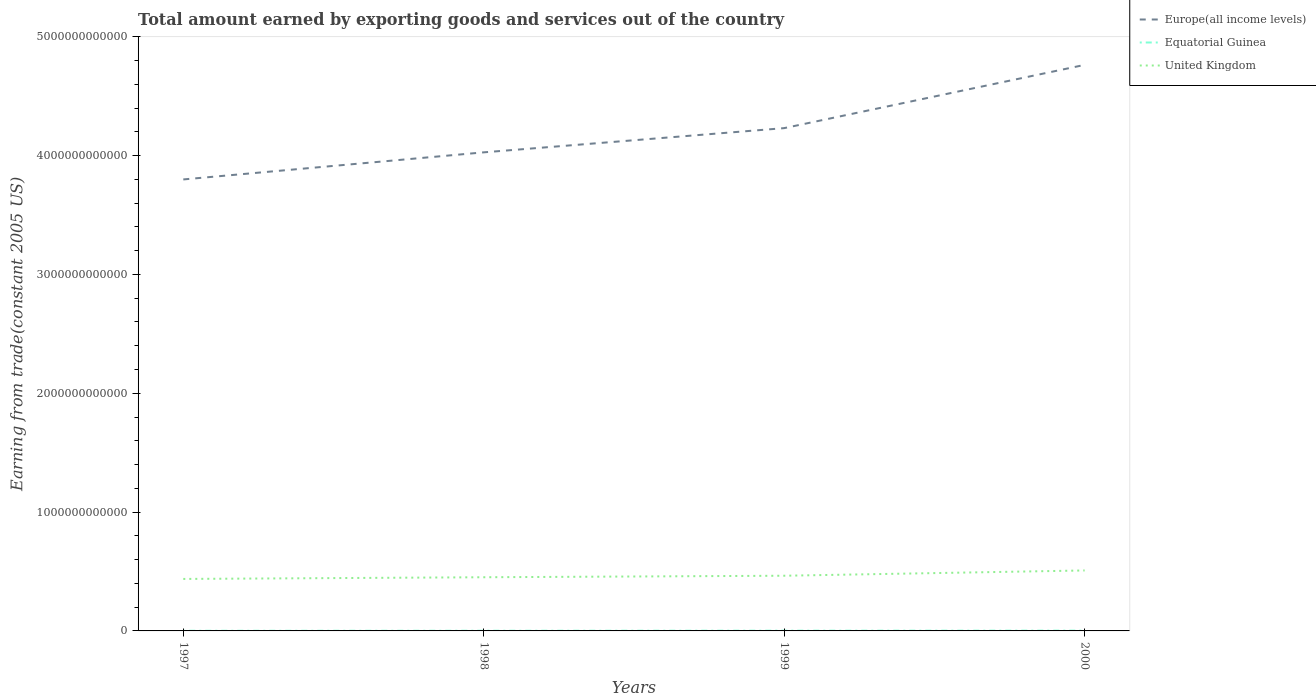Does the line corresponding to United Kingdom intersect with the line corresponding to Equatorial Guinea?
Ensure brevity in your answer.  No. Across all years, what is the maximum total amount earned by exporting goods and services in Europe(all income levels)?
Provide a succinct answer. 3.80e+12. In which year was the total amount earned by exporting goods and services in United Kingdom maximum?
Offer a very short reply. 1997. What is the total total amount earned by exporting goods and services in Equatorial Guinea in the graph?
Offer a very short reply. -2.87e+08. What is the difference between the highest and the second highest total amount earned by exporting goods and services in United Kingdom?
Your response must be concise. 7.14e+1. Is the total amount earned by exporting goods and services in Equatorial Guinea strictly greater than the total amount earned by exporting goods and services in Europe(all income levels) over the years?
Provide a succinct answer. Yes. What is the difference between two consecutive major ticks on the Y-axis?
Keep it short and to the point. 1.00e+12. Are the values on the major ticks of Y-axis written in scientific E-notation?
Give a very brief answer. No. Does the graph contain grids?
Ensure brevity in your answer.  No. Where does the legend appear in the graph?
Provide a short and direct response. Top right. How are the legend labels stacked?
Make the answer very short. Vertical. What is the title of the graph?
Make the answer very short. Total amount earned by exporting goods and services out of the country. Does "Israel" appear as one of the legend labels in the graph?
Provide a succinct answer. No. What is the label or title of the Y-axis?
Make the answer very short. Earning from trade(constant 2005 US). What is the Earning from trade(constant 2005 US) in Europe(all income levels) in 1997?
Offer a terse response. 3.80e+12. What is the Earning from trade(constant 2005 US) of Equatorial Guinea in 1997?
Your answer should be compact. 1.25e+09. What is the Earning from trade(constant 2005 US) of United Kingdom in 1997?
Your answer should be very brief. 4.38e+11. What is the Earning from trade(constant 2005 US) in Europe(all income levels) in 1998?
Offer a very short reply. 4.03e+12. What is the Earning from trade(constant 2005 US) in Equatorial Guinea in 1998?
Your answer should be compact. 1.53e+09. What is the Earning from trade(constant 2005 US) of United Kingdom in 1998?
Keep it short and to the point. 4.52e+11. What is the Earning from trade(constant 2005 US) in Europe(all income levels) in 1999?
Provide a succinct answer. 4.23e+12. What is the Earning from trade(constant 2005 US) in Equatorial Guinea in 1999?
Keep it short and to the point. 2.06e+09. What is the Earning from trade(constant 2005 US) of United Kingdom in 1999?
Your response must be concise. 4.64e+11. What is the Earning from trade(constant 2005 US) of Europe(all income levels) in 2000?
Provide a short and direct response. 4.76e+12. What is the Earning from trade(constant 2005 US) of Equatorial Guinea in 2000?
Make the answer very short. 2.40e+09. What is the Earning from trade(constant 2005 US) in United Kingdom in 2000?
Provide a short and direct response. 5.09e+11. Across all years, what is the maximum Earning from trade(constant 2005 US) of Europe(all income levels)?
Provide a succinct answer. 4.76e+12. Across all years, what is the maximum Earning from trade(constant 2005 US) in Equatorial Guinea?
Ensure brevity in your answer.  2.40e+09. Across all years, what is the maximum Earning from trade(constant 2005 US) of United Kingdom?
Provide a short and direct response. 5.09e+11. Across all years, what is the minimum Earning from trade(constant 2005 US) in Europe(all income levels)?
Make the answer very short. 3.80e+12. Across all years, what is the minimum Earning from trade(constant 2005 US) in Equatorial Guinea?
Your answer should be compact. 1.25e+09. Across all years, what is the minimum Earning from trade(constant 2005 US) in United Kingdom?
Your answer should be very brief. 4.38e+11. What is the total Earning from trade(constant 2005 US) of Europe(all income levels) in the graph?
Offer a terse response. 1.68e+13. What is the total Earning from trade(constant 2005 US) in Equatorial Guinea in the graph?
Provide a succinct answer. 7.24e+09. What is the total Earning from trade(constant 2005 US) in United Kingdom in the graph?
Your response must be concise. 1.86e+12. What is the difference between the Earning from trade(constant 2005 US) in Europe(all income levels) in 1997 and that in 1998?
Offer a terse response. -2.28e+11. What is the difference between the Earning from trade(constant 2005 US) of Equatorial Guinea in 1997 and that in 1998?
Offer a terse response. -2.87e+08. What is the difference between the Earning from trade(constant 2005 US) of United Kingdom in 1997 and that in 1998?
Keep it short and to the point. -1.42e+1. What is the difference between the Earning from trade(constant 2005 US) in Europe(all income levels) in 1997 and that in 1999?
Ensure brevity in your answer.  -4.32e+11. What is the difference between the Earning from trade(constant 2005 US) of Equatorial Guinea in 1997 and that in 1999?
Provide a succinct answer. -8.08e+08. What is the difference between the Earning from trade(constant 2005 US) of United Kingdom in 1997 and that in 1999?
Offer a terse response. -2.70e+1. What is the difference between the Earning from trade(constant 2005 US) of Europe(all income levels) in 1997 and that in 2000?
Give a very brief answer. -9.64e+11. What is the difference between the Earning from trade(constant 2005 US) in Equatorial Guinea in 1997 and that in 2000?
Provide a succinct answer. -1.15e+09. What is the difference between the Earning from trade(constant 2005 US) of United Kingdom in 1997 and that in 2000?
Your answer should be very brief. -7.14e+1. What is the difference between the Earning from trade(constant 2005 US) in Europe(all income levels) in 1998 and that in 1999?
Your answer should be very brief. -2.04e+11. What is the difference between the Earning from trade(constant 2005 US) in Equatorial Guinea in 1998 and that in 1999?
Offer a terse response. -5.22e+08. What is the difference between the Earning from trade(constant 2005 US) of United Kingdom in 1998 and that in 1999?
Keep it short and to the point. -1.28e+1. What is the difference between the Earning from trade(constant 2005 US) in Europe(all income levels) in 1998 and that in 2000?
Provide a succinct answer. -7.36e+11. What is the difference between the Earning from trade(constant 2005 US) in Equatorial Guinea in 1998 and that in 2000?
Offer a very short reply. -8.65e+08. What is the difference between the Earning from trade(constant 2005 US) of United Kingdom in 1998 and that in 2000?
Provide a succinct answer. -5.72e+1. What is the difference between the Earning from trade(constant 2005 US) of Europe(all income levels) in 1999 and that in 2000?
Offer a very short reply. -5.32e+11. What is the difference between the Earning from trade(constant 2005 US) in Equatorial Guinea in 1999 and that in 2000?
Give a very brief answer. -3.43e+08. What is the difference between the Earning from trade(constant 2005 US) in United Kingdom in 1999 and that in 2000?
Give a very brief answer. -4.44e+1. What is the difference between the Earning from trade(constant 2005 US) in Europe(all income levels) in 1997 and the Earning from trade(constant 2005 US) in Equatorial Guinea in 1998?
Give a very brief answer. 3.80e+12. What is the difference between the Earning from trade(constant 2005 US) in Europe(all income levels) in 1997 and the Earning from trade(constant 2005 US) in United Kingdom in 1998?
Offer a terse response. 3.35e+12. What is the difference between the Earning from trade(constant 2005 US) in Equatorial Guinea in 1997 and the Earning from trade(constant 2005 US) in United Kingdom in 1998?
Provide a succinct answer. -4.50e+11. What is the difference between the Earning from trade(constant 2005 US) in Europe(all income levels) in 1997 and the Earning from trade(constant 2005 US) in Equatorial Guinea in 1999?
Provide a short and direct response. 3.80e+12. What is the difference between the Earning from trade(constant 2005 US) in Europe(all income levels) in 1997 and the Earning from trade(constant 2005 US) in United Kingdom in 1999?
Ensure brevity in your answer.  3.33e+12. What is the difference between the Earning from trade(constant 2005 US) in Equatorial Guinea in 1997 and the Earning from trade(constant 2005 US) in United Kingdom in 1999?
Your answer should be compact. -4.63e+11. What is the difference between the Earning from trade(constant 2005 US) of Europe(all income levels) in 1997 and the Earning from trade(constant 2005 US) of Equatorial Guinea in 2000?
Give a very brief answer. 3.80e+12. What is the difference between the Earning from trade(constant 2005 US) in Europe(all income levels) in 1997 and the Earning from trade(constant 2005 US) in United Kingdom in 2000?
Ensure brevity in your answer.  3.29e+12. What is the difference between the Earning from trade(constant 2005 US) of Equatorial Guinea in 1997 and the Earning from trade(constant 2005 US) of United Kingdom in 2000?
Your answer should be compact. -5.08e+11. What is the difference between the Earning from trade(constant 2005 US) in Europe(all income levels) in 1998 and the Earning from trade(constant 2005 US) in Equatorial Guinea in 1999?
Ensure brevity in your answer.  4.03e+12. What is the difference between the Earning from trade(constant 2005 US) in Europe(all income levels) in 1998 and the Earning from trade(constant 2005 US) in United Kingdom in 1999?
Give a very brief answer. 3.56e+12. What is the difference between the Earning from trade(constant 2005 US) in Equatorial Guinea in 1998 and the Earning from trade(constant 2005 US) in United Kingdom in 1999?
Your answer should be compact. -4.63e+11. What is the difference between the Earning from trade(constant 2005 US) in Europe(all income levels) in 1998 and the Earning from trade(constant 2005 US) in Equatorial Guinea in 2000?
Provide a short and direct response. 4.02e+12. What is the difference between the Earning from trade(constant 2005 US) in Europe(all income levels) in 1998 and the Earning from trade(constant 2005 US) in United Kingdom in 2000?
Offer a terse response. 3.52e+12. What is the difference between the Earning from trade(constant 2005 US) in Equatorial Guinea in 1998 and the Earning from trade(constant 2005 US) in United Kingdom in 2000?
Give a very brief answer. -5.07e+11. What is the difference between the Earning from trade(constant 2005 US) in Europe(all income levels) in 1999 and the Earning from trade(constant 2005 US) in Equatorial Guinea in 2000?
Offer a terse response. 4.23e+12. What is the difference between the Earning from trade(constant 2005 US) in Europe(all income levels) in 1999 and the Earning from trade(constant 2005 US) in United Kingdom in 2000?
Keep it short and to the point. 3.72e+12. What is the difference between the Earning from trade(constant 2005 US) of Equatorial Guinea in 1999 and the Earning from trade(constant 2005 US) of United Kingdom in 2000?
Give a very brief answer. -5.07e+11. What is the average Earning from trade(constant 2005 US) in Europe(all income levels) per year?
Provide a succinct answer. 4.21e+12. What is the average Earning from trade(constant 2005 US) of Equatorial Guinea per year?
Your response must be concise. 1.81e+09. What is the average Earning from trade(constant 2005 US) in United Kingdom per year?
Your response must be concise. 4.66e+11. In the year 1997, what is the difference between the Earning from trade(constant 2005 US) of Europe(all income levels) and Earning from trade(constant 2005 US) of Equatorial Guinea?
Your answer should be very brief. 3.80e+12. In the year 1997, what is the difference between the Earning from trade(constant 2005 US) of Europe(all income levels) and Earning from trade(constant 2005 US) of United Kingdom?
Ensure brevity in your answer.  3.36e+12. In the year 1997, what is the difference between the Earning from trade(constant 2005 US) of Equatorial Guinea and Earning from trade(constant 2005 US) of United Kingdom?
Offer a very short reply. -4.36e+11. In the year 1998, what is the difference between the Earning from trade(constant 2005 US) of Europe(all income levels) and Earning from trade(constant 2005 US) of Equatorial Guinea?
Offer a very short reply. 4.03e+12. In the year 1998, what is the difference between the Earning from trade(constant 2005 US) in Europe(all income levels) and Earning from trade(constant 2005 US) in United Kingdom?
Offer a terse response. 3.58e+12. In the year 1998, what is the difference between the Earning from trade(constant 2005 US) of Equatorial Guinea and Earning from trade(constant 2005 US) of United Kingdom?
Offer a very short reply. -4.50e+11. In the year 1999, what is the difference between the Earning from trade(constant 2005 US) of Europe(all income levels) and Earning from trade(constant 2005 US) of Equatorial Guinea?
Your response must be concise. 4.23e+12. In the year 1999, what is the difference between the Earning from trade(constant 2005 US) in Europe(all income levels) and Earning from trade(constant 2005 US) in United Kingdom?
Make the answer very short. 3.77e+12. In the year 1999, what is the difference between the Earning from trade(constant 2005 US) in Equatorial Guinea and Earning from trade(constant 2005 US) in United Kingdom?
Provide a short and direct response. -4.62e+11. In the year 2000, what is the difference between the Earning from trade(constant 2005 US) of Europe(all income levels) and Earning from trade(constant 2005 US) of Equatorial Guinea?
Provide a short and direct response. 4.76e+12. In the year 2000, what is the difference between the Earning from trade(constant 2005 US) in Europe(all income levels) and Earning from trade(constant 2005 US) in United Kingdom?
Offer a very short reply. 4.25e+12. In the year 2000, what is the difference between the Earning from trade(constant 2005 US) in Equatorial Guinea and Earning from trade(constant 2005 US) in United Kingdom?
Your answer should be compact. -5.06e+11. What is the ratio of the Earning from trade(constant 2005 US) of Europe(all income levels) in 1997 to that in 1998?
Offer a very short reply. 0.94. What is the ratio of the Earning from trade(constant 2005 US) in Equatorial Guinea in 1997 to that in 1998?
Ensure brevity in your answer.  0.81. What is the ratio of the Earning from trade(constant 2005 US) of United Kingdom in 1997 to that in 1998?
Ensure brevity in your answer.  0.97. What is the ratio of the Earning from trade(constant 2005 US) in Europe(all income levels) in 1997 to that in 1999?
Make the answer very short. 0.9. What is the ratio of the Earning from trade(constant 2005 US) of Equatorial Guinea in 1997 to that in 1999?
Your answer should be compact. 0.61. What is the ratio of the Earning from trade(constant 2005 US) in United Kingdom in 1997 to that in 1999?
Your answer should be very brief. 0.94. What is the ratio of the Earning from trade(constant 2005 US) in Europe(all income levels) in 1997 to that in 2000?
Offer a terse response. 0.8. What is the ratio of the Earning from trade(constant 2005 US) of Equatorial Guinea in 1997 to that in 2000?
Offer a very short reply. 0.52. What is the ratio of the Earning from trade(constant 2005 US) in United Kingdom in 1997 to that in 2000?
Your response must be concise. 0.86. What is the ratio of the Earning from trade(constant 2005 US) in Europe(all income levels) in 1998 to that in 1999?
Your answer should be very brief. 0.95. What is the ratio of the Earning from trade(constant 2005 US) in Equatorial Guinea in 1998 to that in 1999?
Provide a short and direct response. 0.75. What is the ratio of the Earning from trade(constant 2005 US) of United Kingdom in 1998 to that in 1999?
Make the answer very short. 0.97. What is the ratio of the Earning from trade(constant 2005 US) in Europe(all income levels) in 1998 to that in 2000?
Your response must be concise. 0.85. What is the ratio of the Earning from trade(constant 2005 US) in Equatorial Guinea in 1998 to that in 2000?
Your answer should be compact. 0.64. What is the ratio of the Earning from trade(constant 2005 US) of United Kingdom in 1998 to that in 2000?
Offer a very short reply. 0.89. What is the ratio of the Earning from trade(constant 2005 US) in Europe(all income levels) in 1999 to that in 2000?
Give a very brief answer. 0.89. What is the ratio of the Earning from trade(constant 2005 US) of Equatorial Guinea in 1999 to that in 2000?
Your answer should be compact. 0.86. What is the ratio of the Earning from trade(constant 2005 US) of United Kingdom in 1999 to that in 2000?
Provide a short and direct response. 0.91. What is the difference between the highest and the second highest Earning from trade(constant 2005 US) in Europe(all income levels)?
Offer a very short reply. 5.32e+11. What is the difference between the highest and the second highest Earning from trade(constant 2005 US) of Equatorial Guinea?
Your answer should be very brief. 3.43e+08. What is the difference between the highest and the second highest Earning from trade(constant 2005 US) in United Kingdom?
Provide a succinct answer. 4.44e+1. What is the difference between the highest and the lowest Earning from trade(constant 2005 US) of Europe(all income levels)?
Offer a very short reply. 9.64e+11. What is the difference between the highest and the lowest Earning from trade(constant 2005 US) of Equatorial Guinea?
Your answer should be very brief. 1.15e+09. What is the difference between the highest and the lowest Earning from trade(constant 2005 US) in United Kingdom?
Offer a terse response. 7.14e+1. 